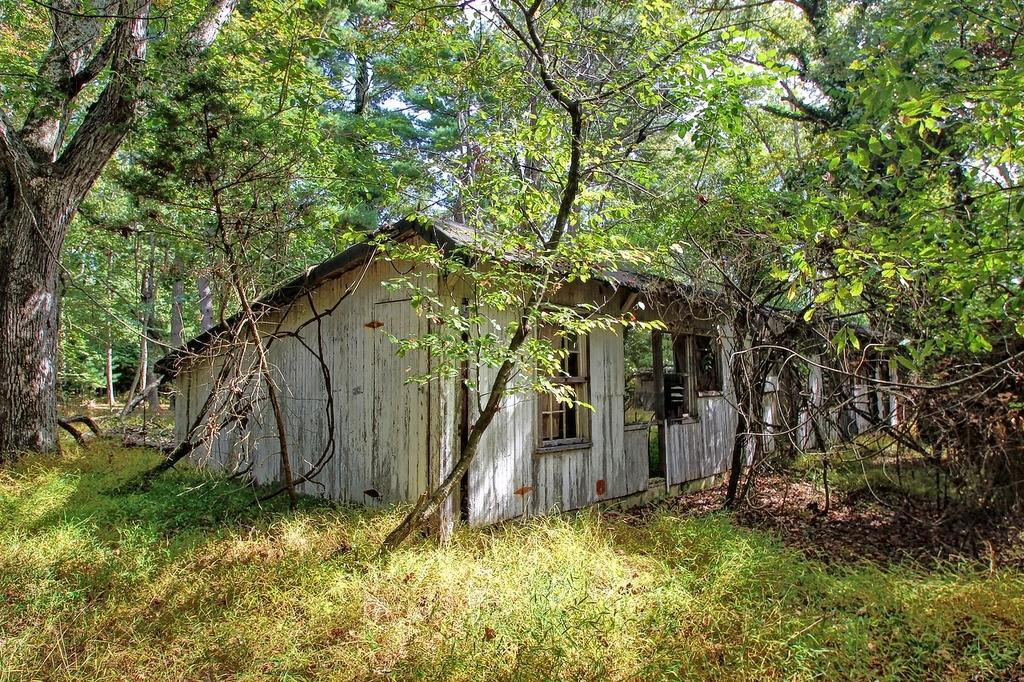What type of structure is visible in the image? There is a house in the image. What natural elements can be seen in the image? There are many trees and grass present in the image. What can be found at the bottom of the image? Dried leaves are visible at the bottom of the image. What type of calendar is hanging on the wall inside the house in the image? There is no calendar visible in the image, as it only shows the exterior of the house and its surroundings. 